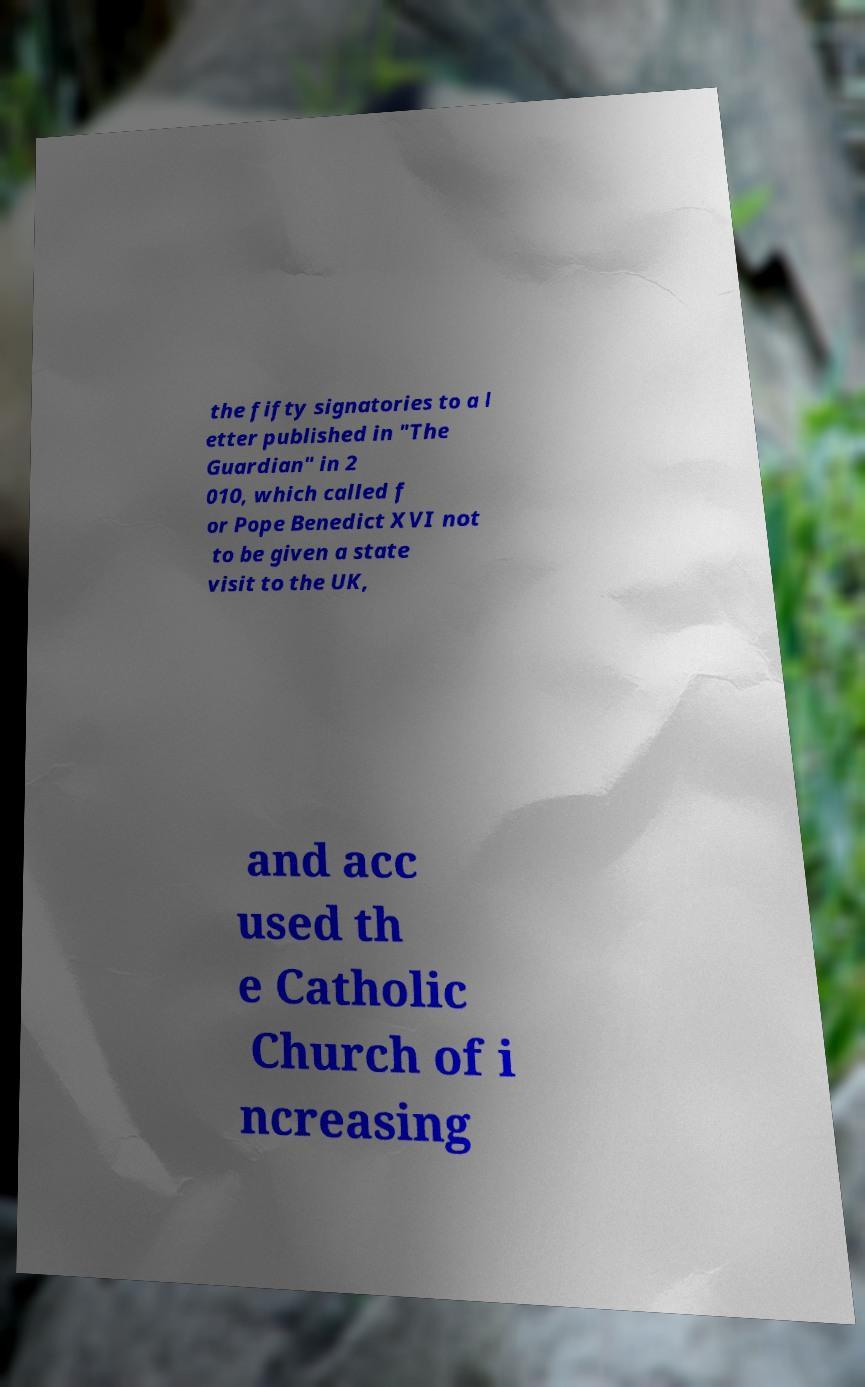Can you accurately transcribe the text from the provided image for me? the fifty signatories to a l etter published in "The Guardian" in 2 010, which called f or Pope Benedict XVI not to be given a state visit to the UK, and acc used th e Catholic Church of i ncreasing 